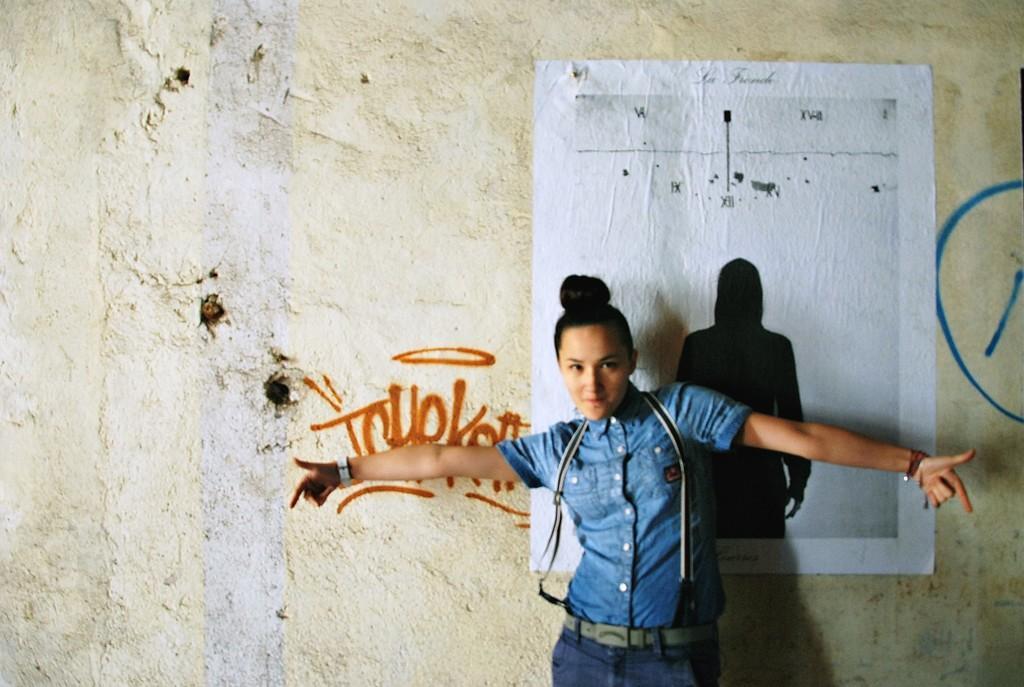Can you describe this image briefly? In this image we can see a person standing and wearing a bag, in the background, we can see the wall, on the wall there is a poster and text. 